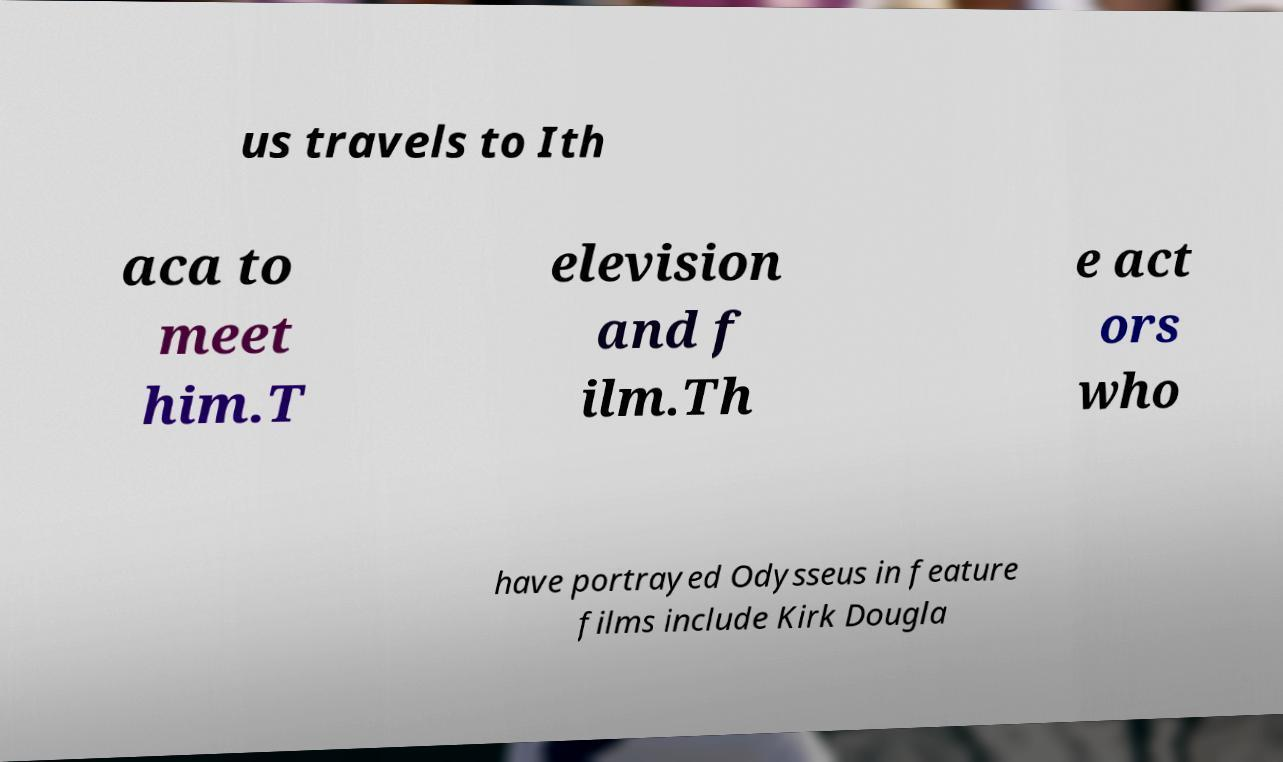Please read and relay the text visible in this image. What does it say? us travels to Ith aca to meet him.T elevision and f ilm.Th e act ors who have portrayed Odysseus in feature films include Kirk Dougla 